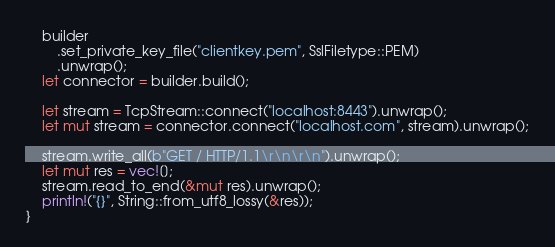<code> <loc_0><loc_0><loc_500><loc_500><_Rust_>    builder
        .set_private_key_file("clientkey.pem", SslFiletype::PEM)
        .unwrap();
    let connector = builder.build();

    let stream = TcpStream::connect("localhost:8443").unwrap();
    let mut stream = connector.connect("localhost.com", stream).unwrap();

    stream.write_all(b"GET / HTTP/1.1\r\n\r\n").unwrap();
    let mut res = vec![];
    stream.read_to_end(&mut res).unwrap();
    println!("{}", String::from_utf8_lossy(&res));
}
</code> 